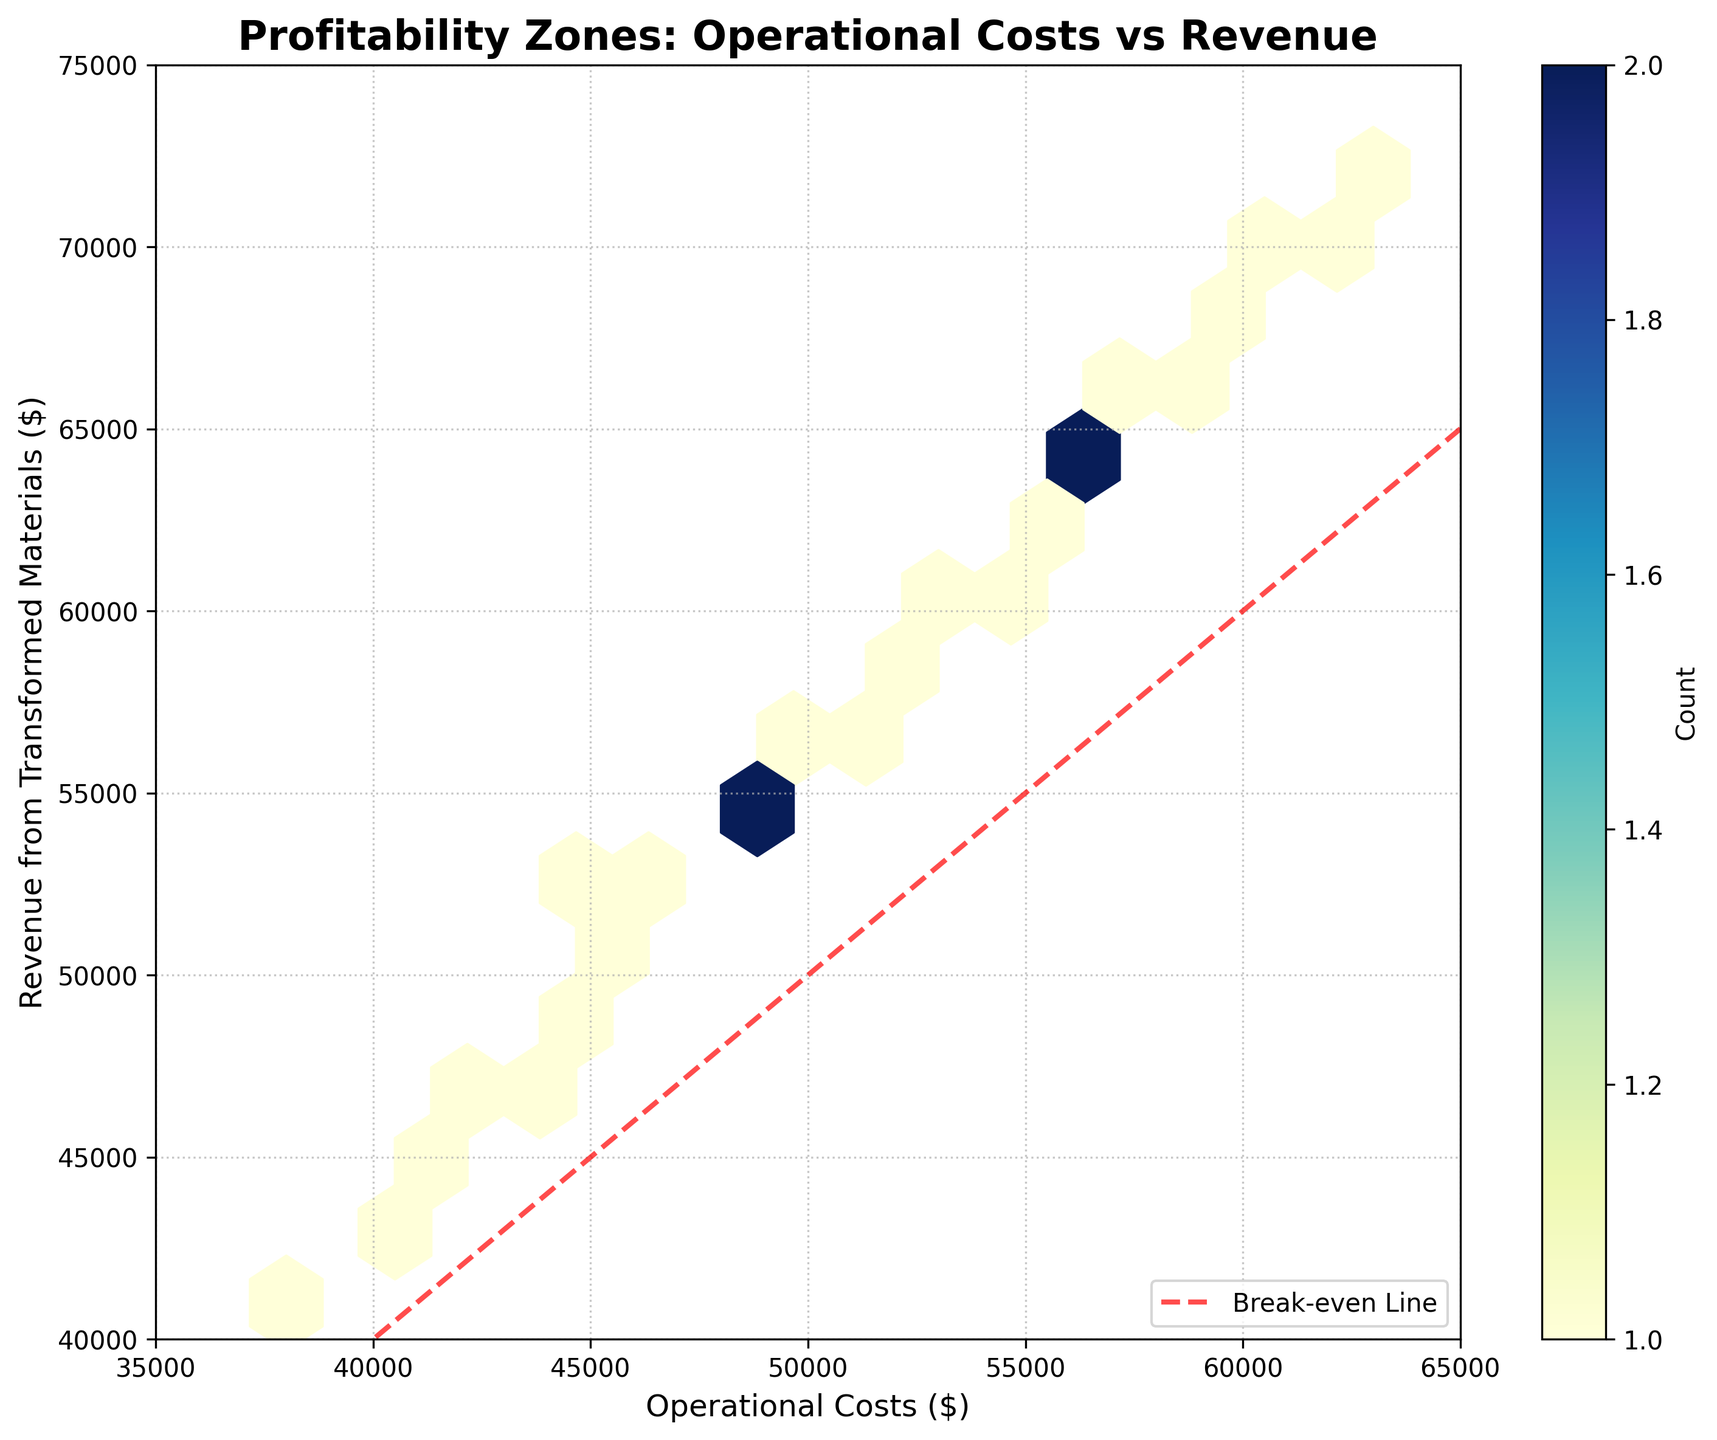What is the title of the plot? The title is usually shown at the top of the plot, which clearly describes what the plot is about. In this case, the title is "Profitability Zones: Operational Costs vs Revenue"
Answer: Profitability Zones: Operational Costs vs Revenue What are the labels on the x-axis and y-axis? Axis labels are placed along the axes to describe what the data points represent. Here, the x-axis label is "Operational Costs ($)", and the y-axis label is "Revenue from Transformed Materials ($)".
Answer: Operational Costs ($), Revenue from Transformed Materials ($) What color is used for the break-even line in the plot? The break-even line is typically drawn to illustrate where operational costs are equal to revenue. It's shown using a dashed red line going through the plot.
Answer: Red Between which ranges do the x-axis and y-axis values fall? The x-axis values range from 35,000 to 65,000, while the y-axis values range from 40,000 to 75,000 as indicated by the axis limits set in the plot.
Answer: 35,000 to 65,000 (x-axis), 40,000 to 75,000 (y-axis) On the plot, do most points lie above or below the break-even line? Observing the density and distribution of the hexagons, most data points fall above the red break-even line, indicating that revenues are often higher than operational costs.
Answer: Above What is the significance of the color gradient on the hexagons? The color gradient on the hexagons represents the count (density) of data points in that area. Darker colors (e.g., dark blue) indicate a higher concentration of data points. The color bar on the side shows this.
Answer: Density of data points Are there any areas where profits are particularly high or low? High-profit areas would be where revenue is significantly higher than operational costs and have denser hexagons, likely in the upper section of the plot above the break-even line. Similarly, lower profit zones will be near or below the break-even line.
Answer: Upper section above break-even line How many distinct profitability zones can you identify based on the plot? From the visual clustering of the hexagons and the break-even line, there appear to be distinct zones: high profitability (far above the line), moderate profitability (slightly above), break-even (along the line), and loss (below the line).
Answer: Four zones Based on the hexbin color gradient, what is the highest density area for operational costs and revenue? The highest density area, where hexagons are darkest, indicates a clustering of points around $50,000 to $60,000 in operational costs and $55,000 to $65,000 in revenue.
Answer: $50,000-$60,000 (costs) and $55,000-$65,000 (revenue) What is the function of the grid shown on the plot? The grid helps in visual alignment and makes it easier to locate the exact positions of data points on the plot, aiding in the interpretation of operations and profitability.
Answer: Helps in visual alignment and data interpretation 